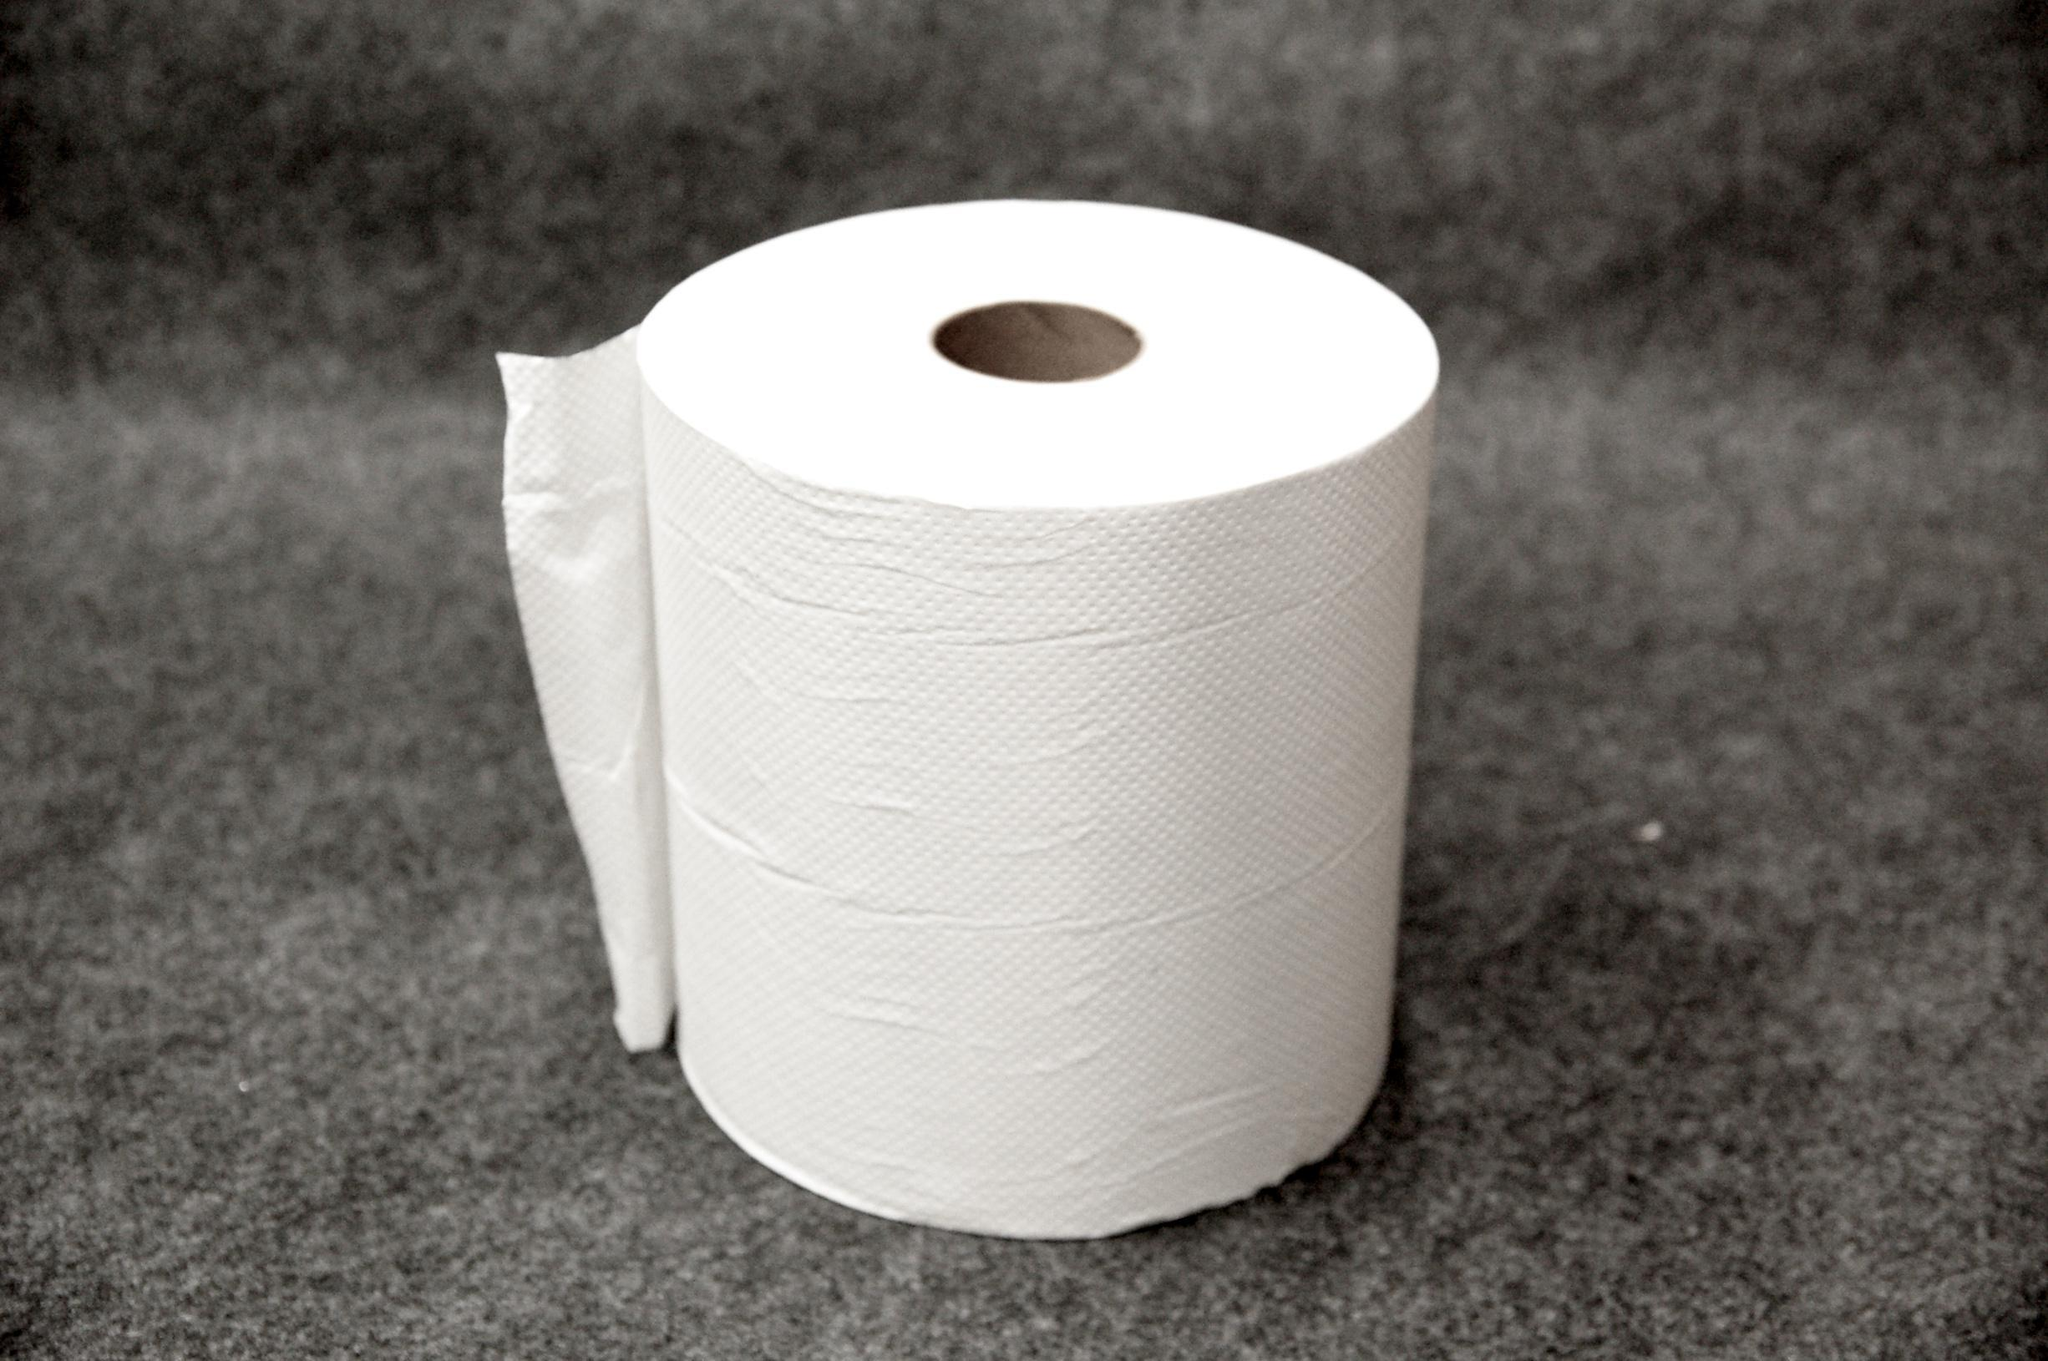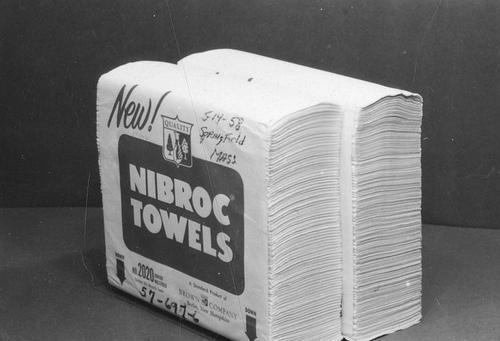The first image is the image on the left, the second image is the image on the right. Given the left and right images, does the statement "One image shows white paper towels that are not in roll format." hold true? Answer yes or no. Yes. 